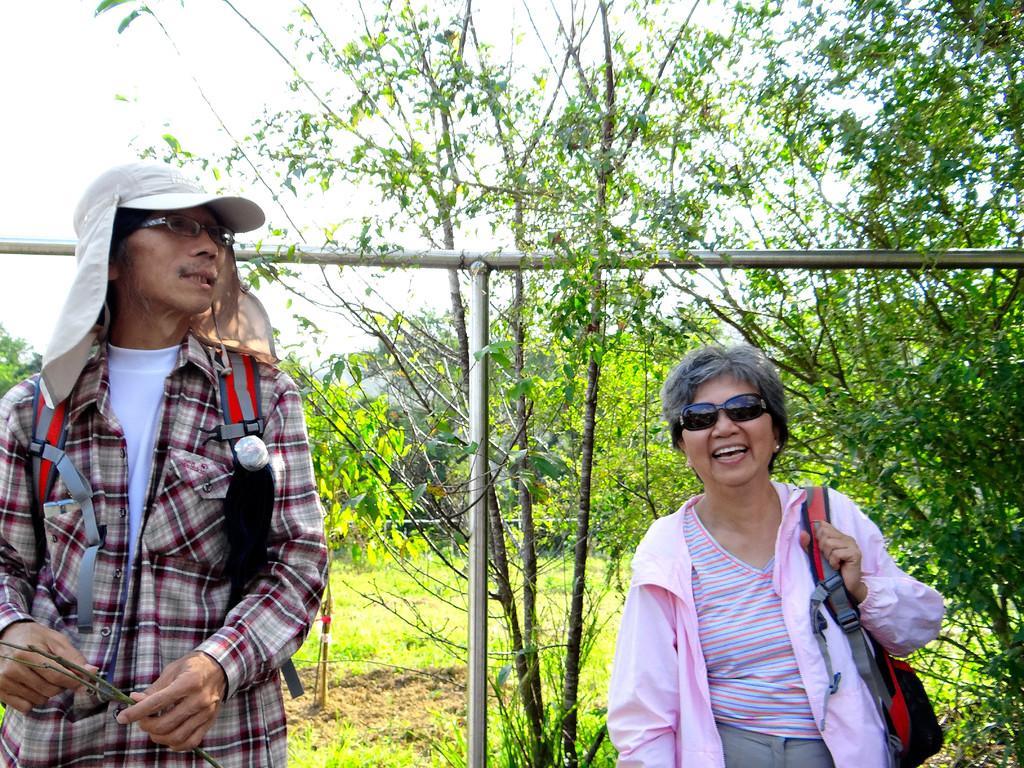How would you summarize this image in a sentence or two? In this picture we can see two people carrying bags, smiling and at the back of them we can see the grass, trees, poles and in the background we can see the sky. 